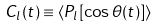<formula> <loc_0><loc_0><loc_500><loc_500>C _ { l } ( t ) \equiv \langle P _ { l } [ \cos \theta ( t ) ] \rangle</formula> 